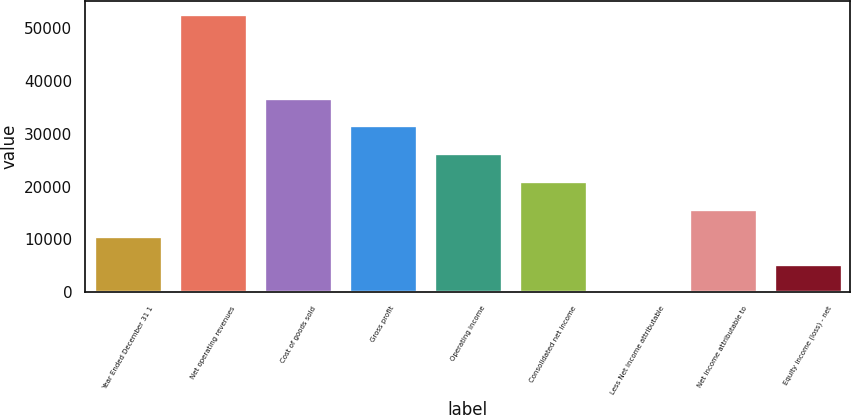Convert chart. <chart><loc_0><loc_0><loc_500><loc_500><bar_chart><fcel>Year Ended December 31 1<fcel>Net operating revenues<fcel>Cost of goods sold<fcel>Gross profit<fcel>Operating income<fcel>Consolidated net income<fcel>Less Net income attributable<fcel>Net income attributable to<fcel>Equity income (loss) - net<nl><fcel>10584.6<fcel>52627<fcel>36861.1<fcel>31605.8<fcel>26350.5<fcel>21095.2<fcel>74<fcel>15839.9<fcel>5329.3<nl></chart> 